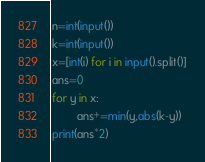Convert code to text. <code><loc_0><loc_0><loc_500><loc_500><_Python_>n=int(input())
k=int(input())
x=[int(i) for i in input().split()]
ans=0
for y in x:
        ans+=min(y,abs(k-y))
print(ans*2)</code> 